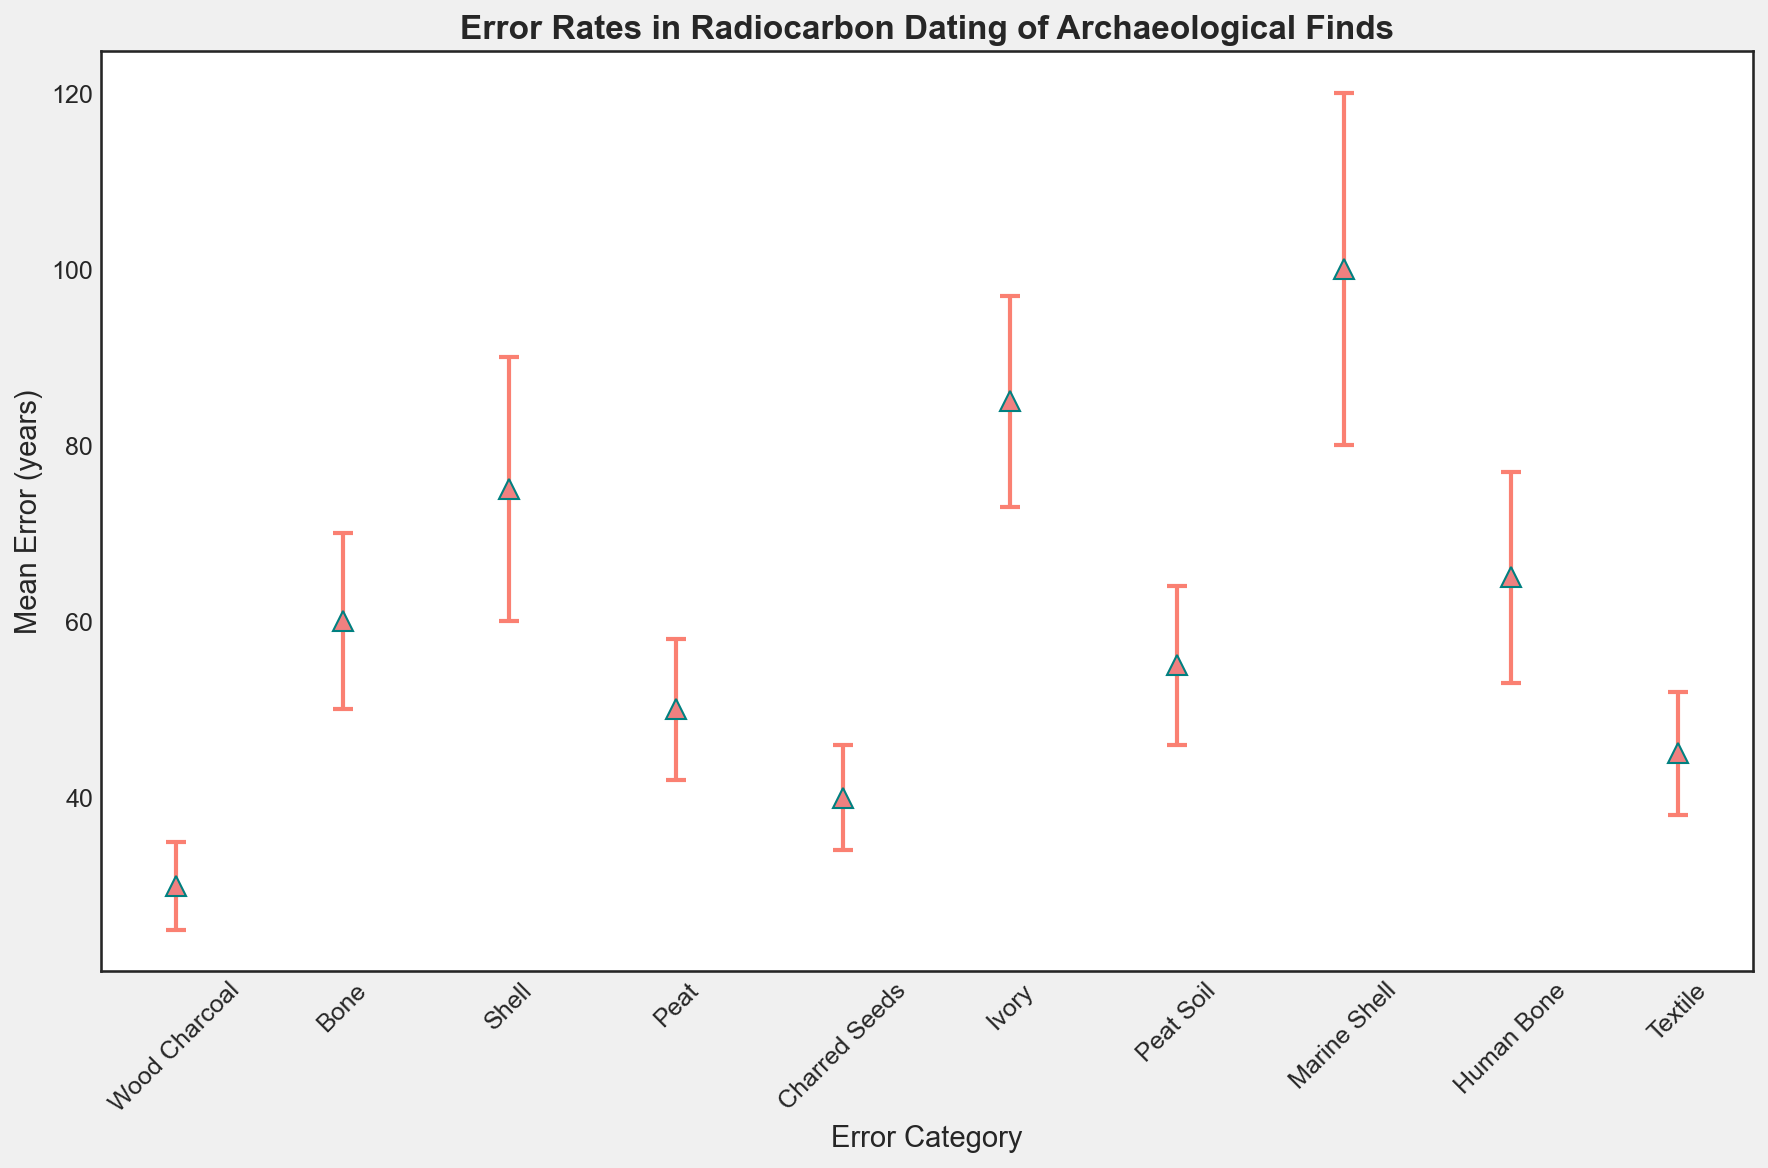What is the mean error for marine shells? Locate the "Marine Shell" category on the x-axis and trace upwards to the corresponding data point. The mean error is 100 years.
Answer: 100 years Which error category has the smallest mean error? Identify all plotted mean error values and find the smallest one. "Wood Charcoal" has the smallest mean error at 30 years.
Answer: Wood Charcoal How much greater is the mean error for marine shells compared to wood charcoal? Find the mean errors for Marine Shell (100 years) and Wood Charcoal (30 years). Subtract the smaller value from the larger one: 100 - 30 = 70 years.
Answer: 70 years Which error category has a mean error margin of 5 years? Locate the error margins, and find the corresponding category with an error margin of 5 years, which is "Wood Charcoal".
Answer: Wood Charcoal What is the average mean error of Bone, Shell, and Peat Soil combined? Find the mean errors for Bone (60 years), Shell (75 years), and Peat Soil (55 years). Calculate the average: (60 + 75 + 55) / 3 = 190 / 3 ≈ 63.33 years.
Answer: 63.33 years Which category has a mean error closest to 50 years? Compare the mean errors to 50 years. "Peat" has a mean error of 50 years, matching exactly.
Answer: Peat Rank the categories from highest to lowest mean error. List down all mean errors and sort them: Marine Shell (100), Ivory (85), Human Bone (65), Shell (75), Bone (60), Peat Soil (55), Peat (50), Textile (45), Charred Seeds (40), Wood Charcoal (30).
Answer: Marine Shell, Ivory, Shell, Human Bone, Bone, Peat Soil, Peat, Textile, Charred Seeds, Wood Charcoal What is the mean error range displayed in the plot (difference between highest and lowest mean errors)? Find the highest mean error (Marine Shell, 100 years) and the lowest mean error (Wood Charcoal, 30 years). Subtract the smallest value from the largest: 100 - 30 = 70 years.
Answer: 70 years Which two categories have the most similar mean error margins? Compare the error margins visually and find the most similar pair: Peat and Human Bone both have error margins very close to each other (Peat: 8 years, Human Bone: 12 years).
Answer: Peat and Human Bone 